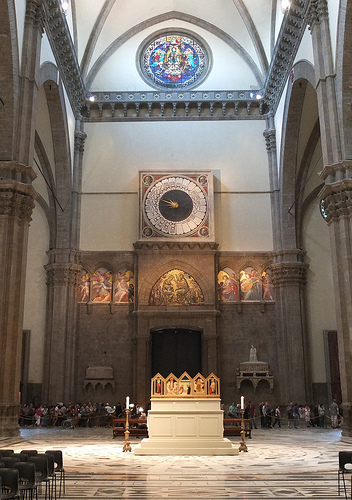On which side of the picture is the statue? The statue is located on the right side of the picture. 